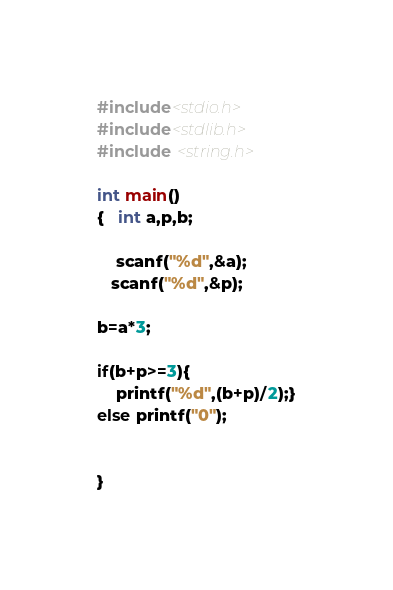<code> <loc_0><loc_0><loc_500><loc_500><_C_>#include<stdio.h>
#include<stdlib.h>
#include <string.h>

int main()
{   int a,p,b;
 
    scanf("%d",&a);
   scanf("%d",&p);
    
b=a*3;

if(b+p>=3){
	printf("%d",(b+p)/2);}
else printf("0");


}</code> 